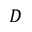Convert formula to latex. <formula><loc_0><loc_0><loc_500><loc_500>D</formula> 